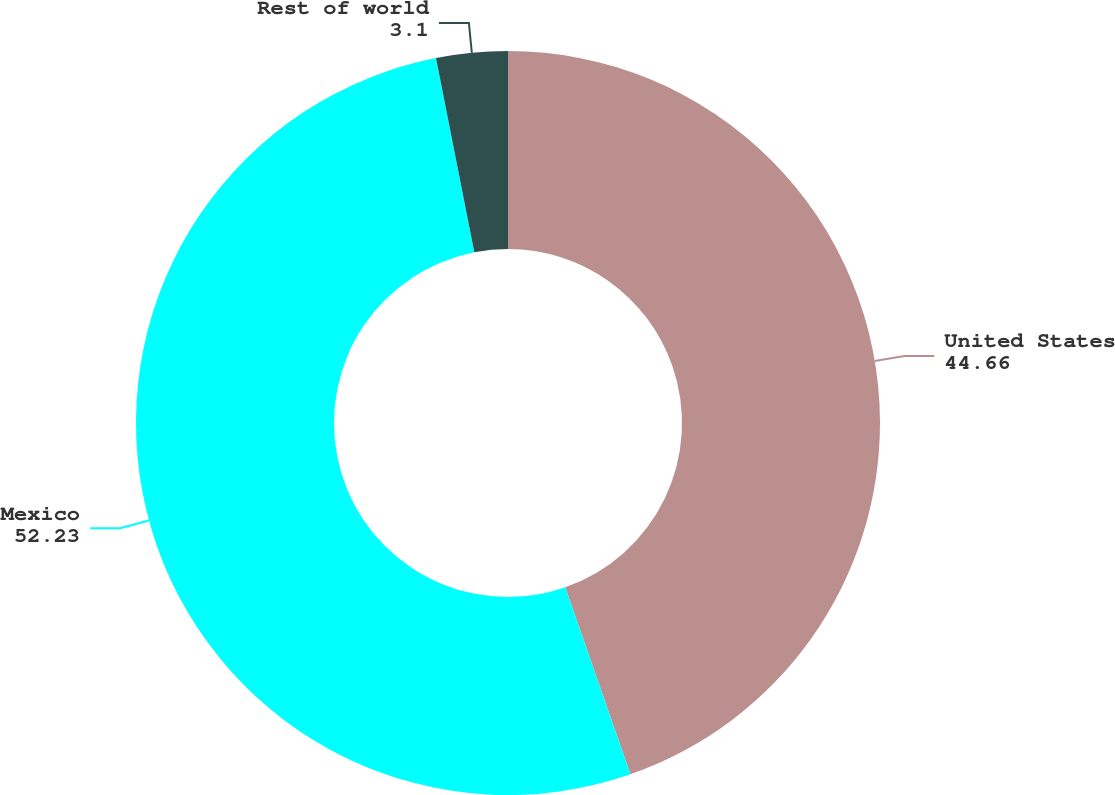<chart> <loc_0><loc_0><loc_500><loc_500><pie_chart><fcel>United States<fcel>Mexico<fcel>Rest of world<nl><fcel>44.66%<fcel>52.23%<fcel>3.1%<nl></chart> 